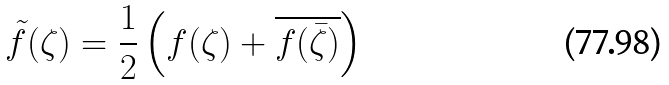Convert formula to latex. <formula><loc_0><loc_0><loc_500><loc_500>\tilde { f } ( \zeta ) = \frac { 1 } { 2 } \left ( f ( \zeta ) + \overline { f ( \bar { \zeta } ) } \right )</formula> 